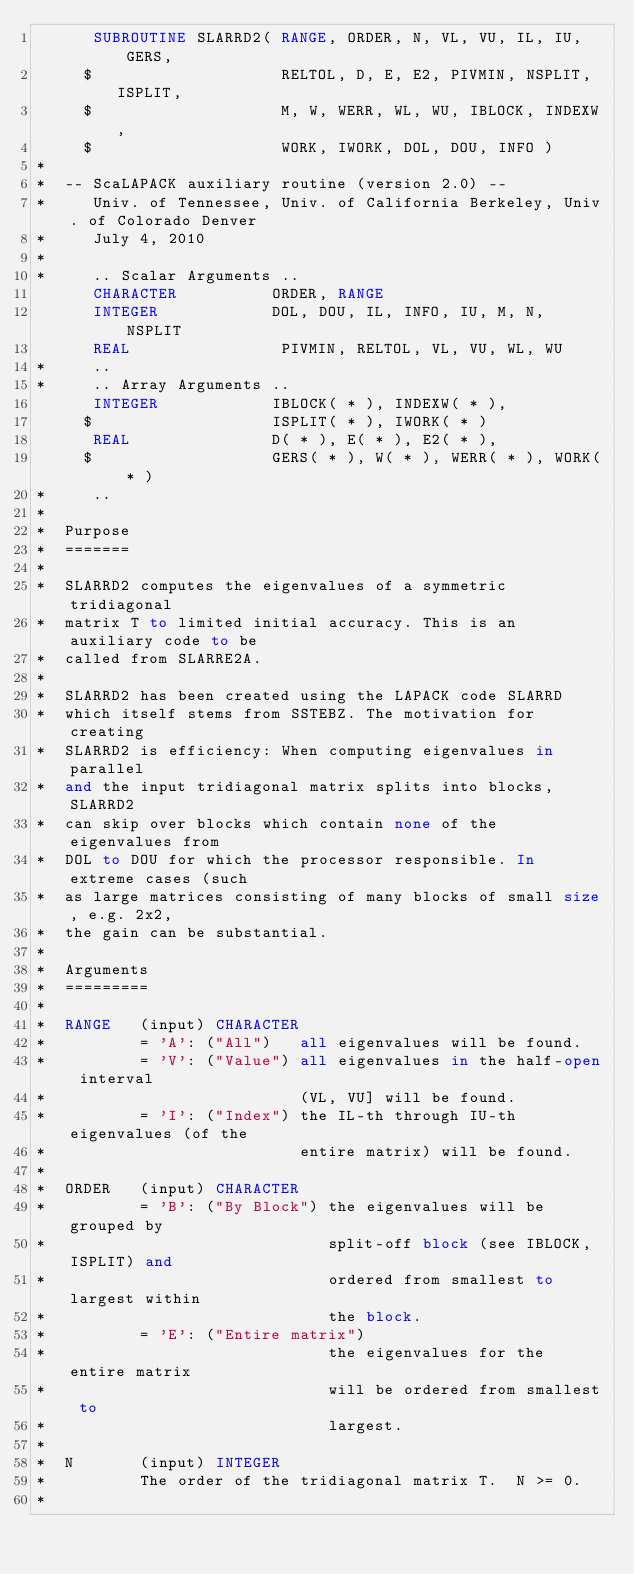<code> <loc_0><loc_0><loc_500><loc_500><_FORTRAN_>      SUBROUTINE SLARRD2( RANGE, ORDER, N, VL, VU, IL, IU, GERS, 
     $                    RELTOL, D, E, E2, PIVMIN, NSPLIT, ISPLIT, 
     $                    M, W, WERR, WL, WU, IBLOCK, INDEXW, 
     $                    WORK, IWORK, DOL, DOU, INFO )
*
*  -- ScaLAPACK auxiliary routine (version 2.0) --
*     Univ. of Tennessee, Univ. of California Berkeley, Univ. of Colorado Denver
*     July 4, 2010
*
*     .. Scalar Arguments ..
      CHARACTER          ORDER, RANGE
      INTEGER            DOL, DOU, IL, INFO, IU, M, N, NSPLIT
      REAL                PIVMIN, RELTOL, VL, VU, WL, WU
*     ..
*     .. Array Arguments ..
      INTEGER            IBLOCK( * ), INDEXW( * ), 
     $                   ISPLIT( * ), IWORK( * )
      REAL               D( * ), E( * ), E2( * ), 
     $                   GERS( * ), W( * ), WERR( * ), WORK( * )
*     ..
*
*  Purpose
*  =======
*
*  SLARRD2 computes the eigenvalues of a symmetric tridiagonal
*  matrix T to limited initial accuracy. This is an auxiliary code to be 
*  called from SLARRE2A.
* 
*  SLARRD2 has been created using the LAPACK code SLARRD
*  which itself stems from SSTEBZ. The motivation for creating
*  SLARRD2 is efficiency: When computing eigenvalues in parallel
*  and the input tridiagonal matrix splits into blocks, SLARRD2 
*  can skip over blocks which contain none of the eigenvalues from
*  DOL to DOU for which the processor responsible. In extreme cases (such
*  as large matrices consisting of many blocks of small size, e.g. 2x2,
*  the gain can be substantial.
*
*  Arguments
*  =========
*
*  RANGE   (input) CHARACTER
*          = 'A': ("All")   all eigenvalues will be found.
*          = 'V': ("Value") all eigenvalues in the half-open interval
*                           (VL, VU] will be found.
*          = 'I': ("Index") the IL-th through IU-th eigenvalues (of the
*                           entire matrix) will be found.
*
*  ORDER   (input) CHARACTER
*          = 'B': ("By Block") the eigenvalues will be grouped by
*                              split-off block (see IBLOCK, ISPLIT) and
*                              ordered from smallest to largest within
*                              the block.
*          = 'E': ("Entire matrix")
*                              the eigenvalues for the entire matrix
*                              will be ordered from smallest to
*                              largest.
*
*  N       (input) INTEGER
*          The order of the tridiagonal matrix T.  N >= 0.
*</code> 